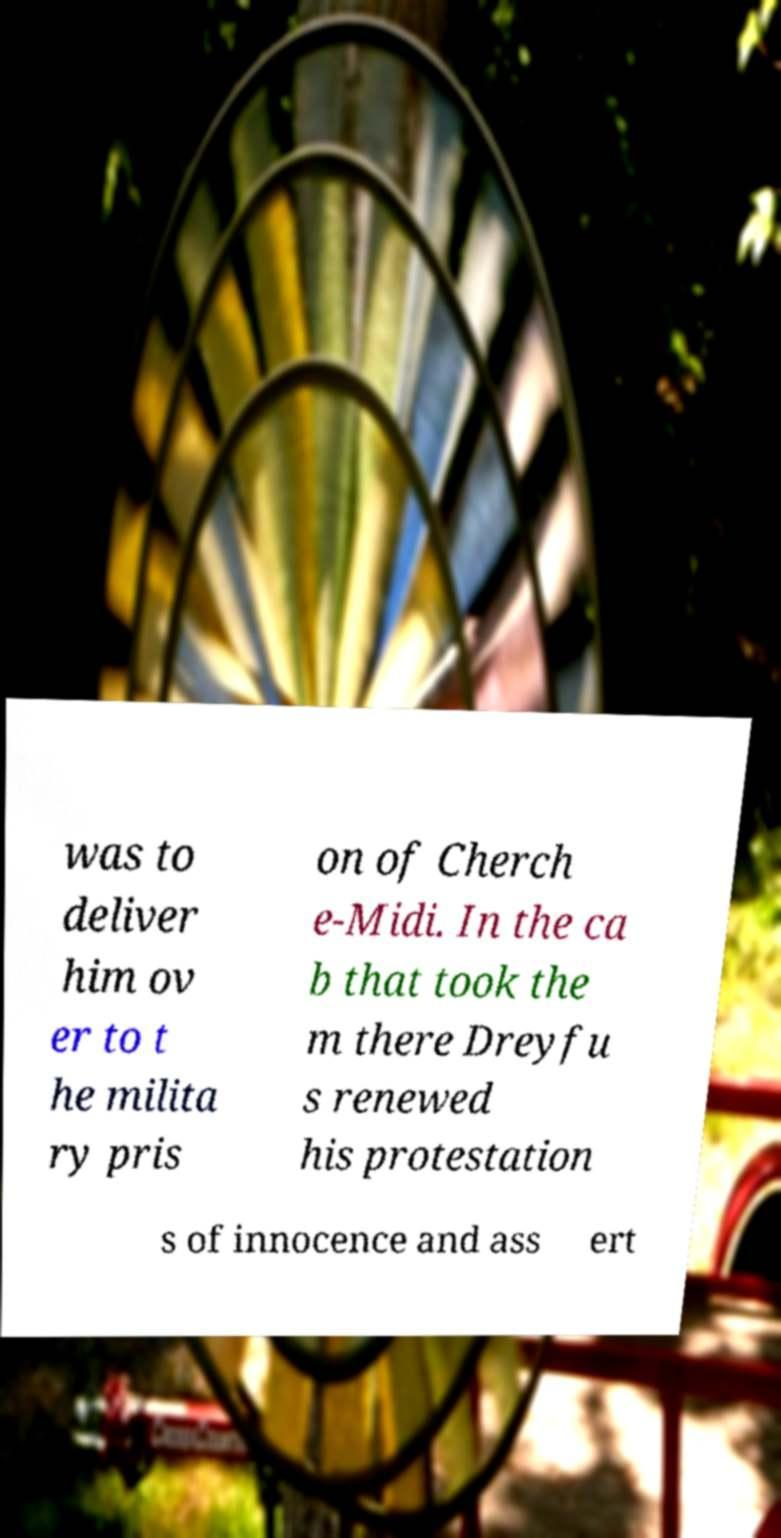Could you assist in decoding the text presented in this image and type it out clearly? was to deliver him ov er to t he milita ry pris on of Cherch e-Midi. In the ca b that took the m there Dreyfu s renewed his protestation s of innocence and ass ert 